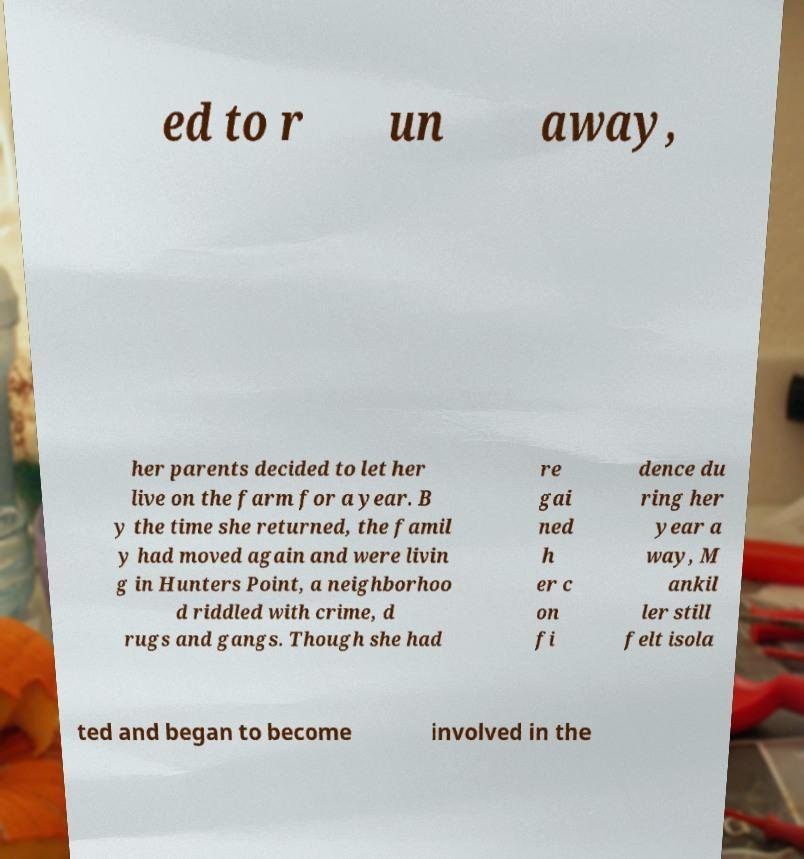What messages or text are displayed in this image? I need them in a readable, typed format. ed to r un away, her parents decided to let her live on the farm for a year. B y the time she returned, the famil y had moved again and were livin g in Hunters Point, a neighborhoo d riddled with crime, d rugs and gangs. Though she had re gai ned h er c on fi dence du ring her year a way, M ankil ler still felt isola ted and began to become involved in the 